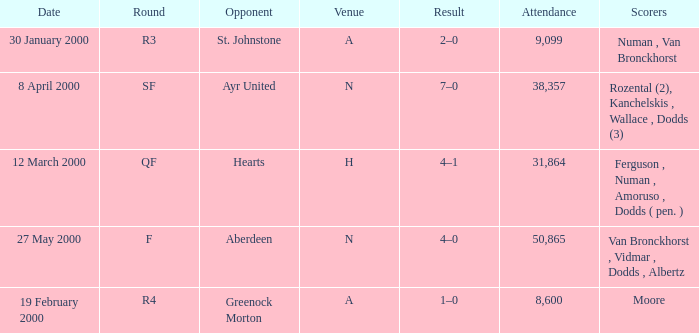Who was on 12 March 2000? Ferguson , Numan , Amoruso , Dodds ( pen. ). 